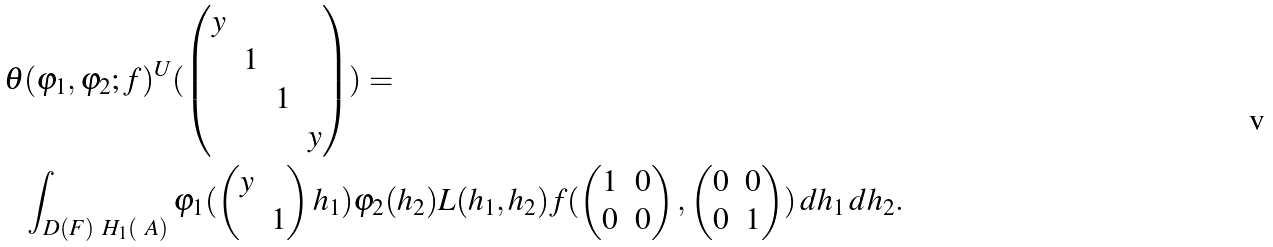<formula> <loc_0><loc_0><loc_500><loc_500>\theta & ( \varphi _ { 1 } , \varphi _ { 2 } ; f ) ^ { U } ( \begin{pmatrix} y \\ & 1 \\ & & 1 \\ & & & y \end{pmatrix} ) = \\ & \int _ { D ( F ) \ H _ { 1 } ( \ A ) } \varphi _ { 1 } ( \begin{pmatrix} y \\ & 1 \end{pmatrix} h _ { 1 } ) \varphi _ { 2 } ( h _ { 2 } ) L ( h _ { 1 } , h _ { 2 } ) f ( \begin{pmatrix} 1 & 0 \\ 0 & 0 \end{pmatrix} , \begin{pmatrix} 0 & 0 \\ 0 & 1 \end{pmatrix} ) \, d h _ { 1 } \, d h _ { 2 } .</formula> 